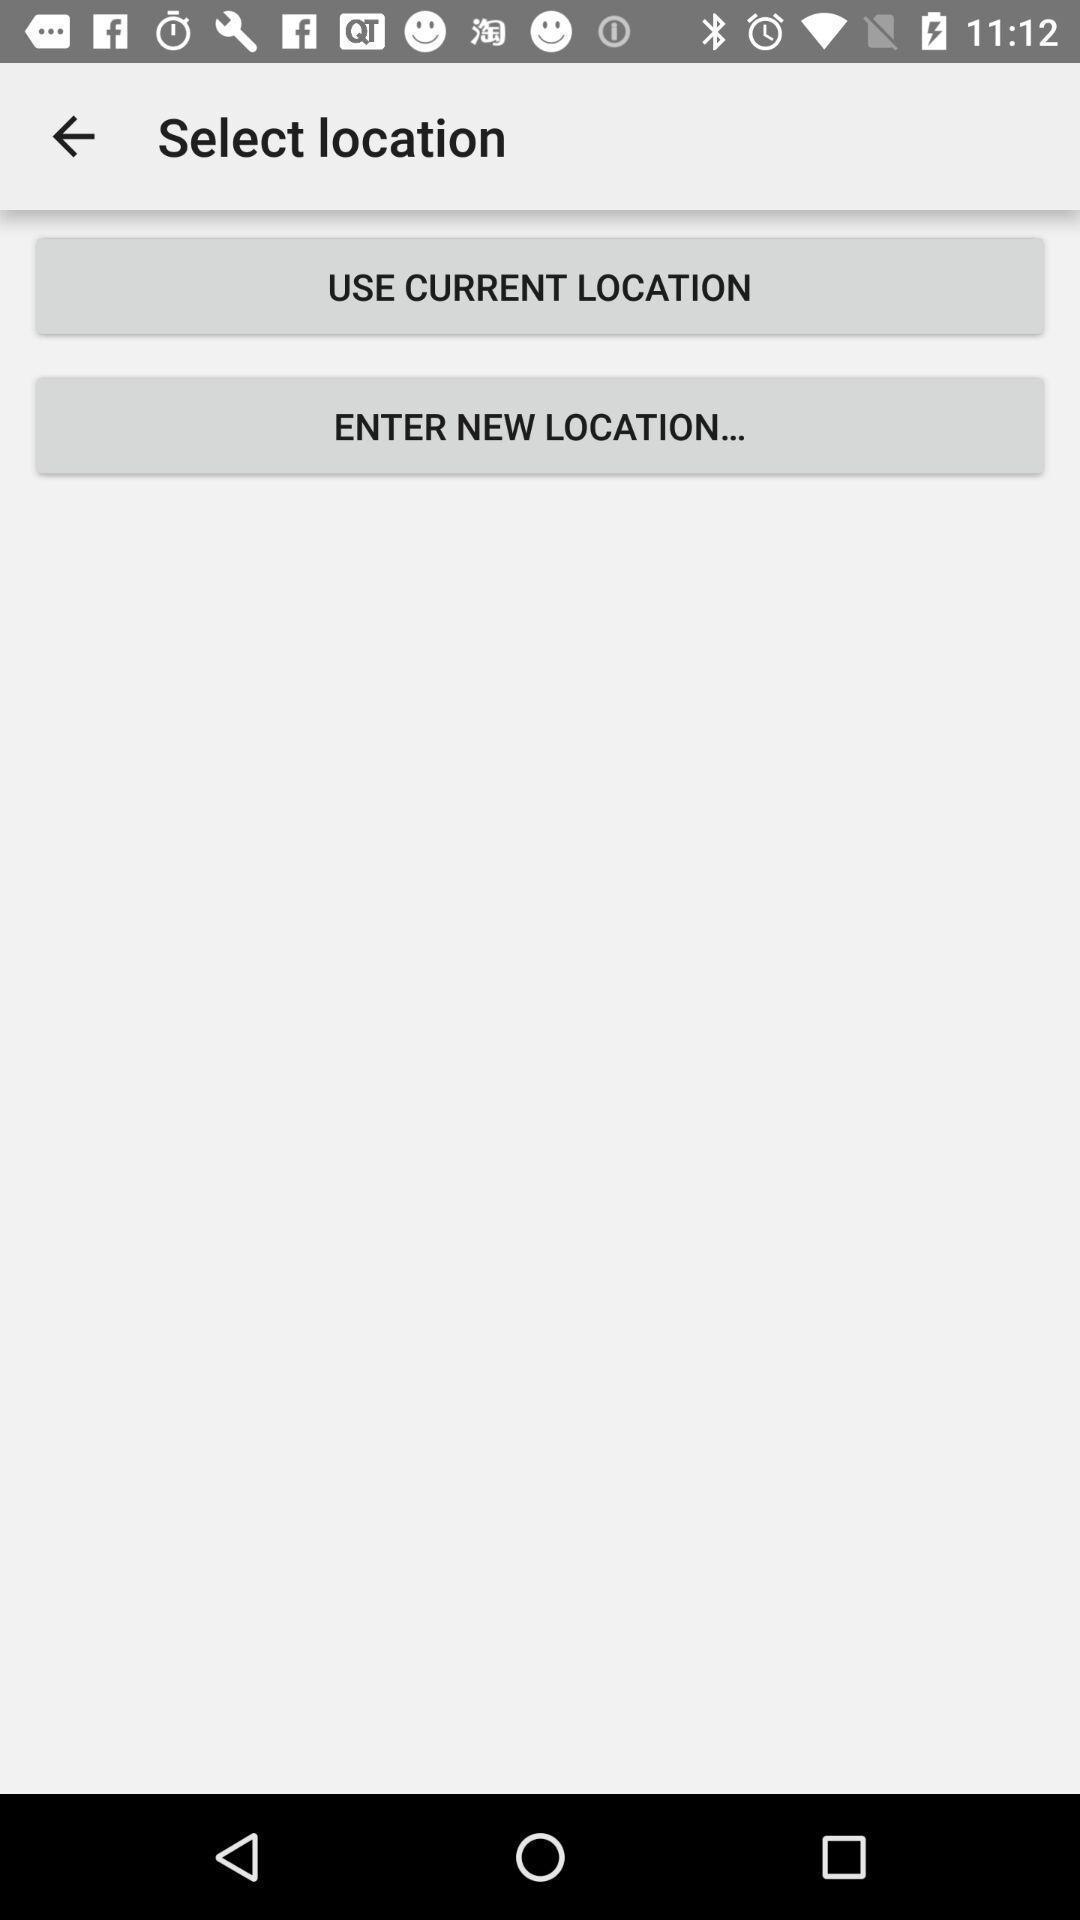Provide a textual representation of this image. Screen shows multiple options. 